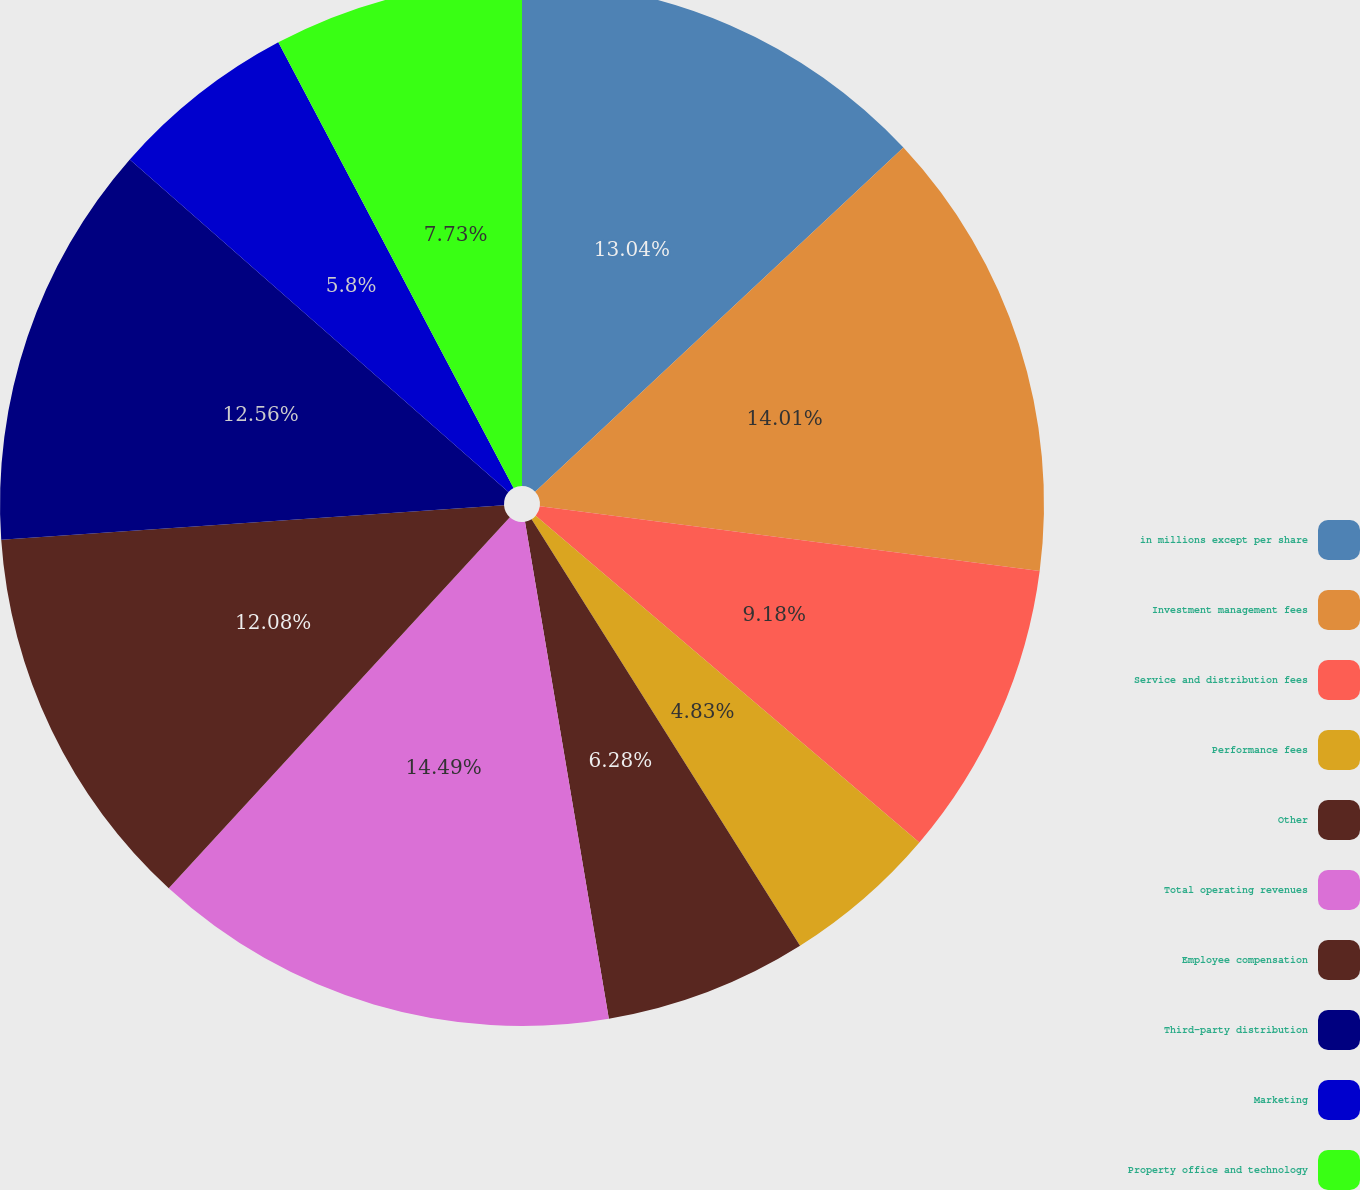<chart> <loc_0><loc_0><loc_500><loc_500><pie_chart><fcel>in millions except per share<fcel>Investment management fees<fcel>Service and distribution fees<fcel>Performance fees<fcel>Other<fcel>Total operating revenues<fcel>Employee compensation<fcel>Third-party distribution<fcel>Marketing<fcel>Property office and technology<nl><fcel>13.04%<fcel>14.01%<fcel>9.18%<fcel>4.83%<fcel>6.28%<fcel>14.49%<fcel>12.08%<fcel>12.56%<fcel>5.8%<fcel>7.73%<nl></chart> 